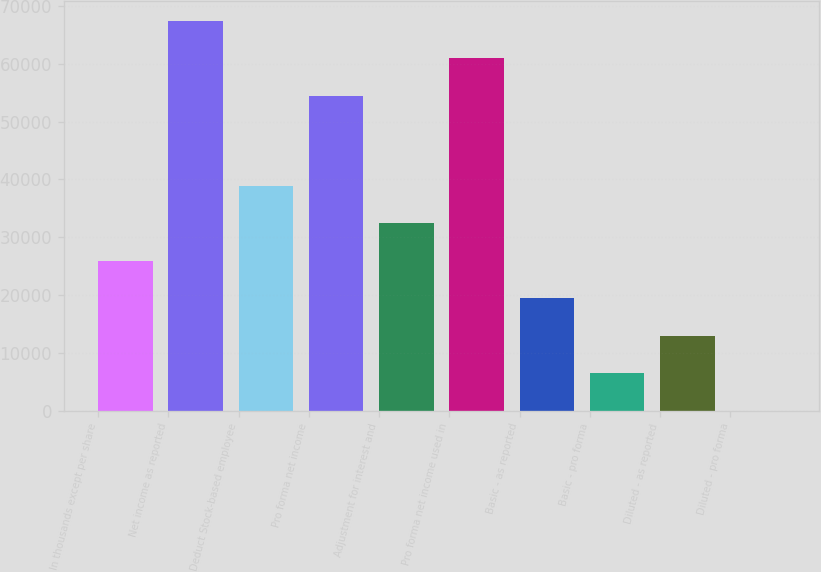<chart> <loc_0><loc_0><loc_500><loc_500><bar_chart><fcel>In thousands except per share<fcel>Net income as reported<fcel>Deduct Stock-based employee<fcel>Pro forma net income<fcel>Adjustment for interest and<fcel>Pro forma net income used in<fcel>Basic - as reported<fcel>Basic - pro forma<fcel>Diluted - as reported<fcel>Diluted - pro forma<nl><fcel>25914.5<fcel>67418.8<fcel>38871.3<fcel>54462<fcel>32392.9<fcel>60940.4<fcel>19436<fcel>6479.19<fcel>12957.6<fcel>0.77<nl></chart> 